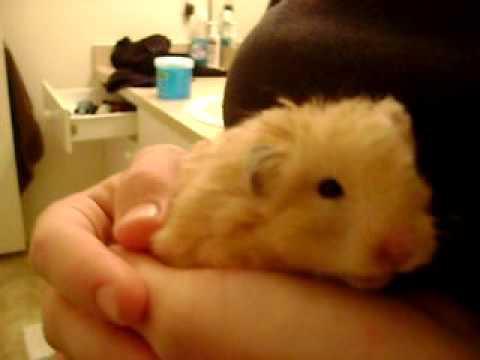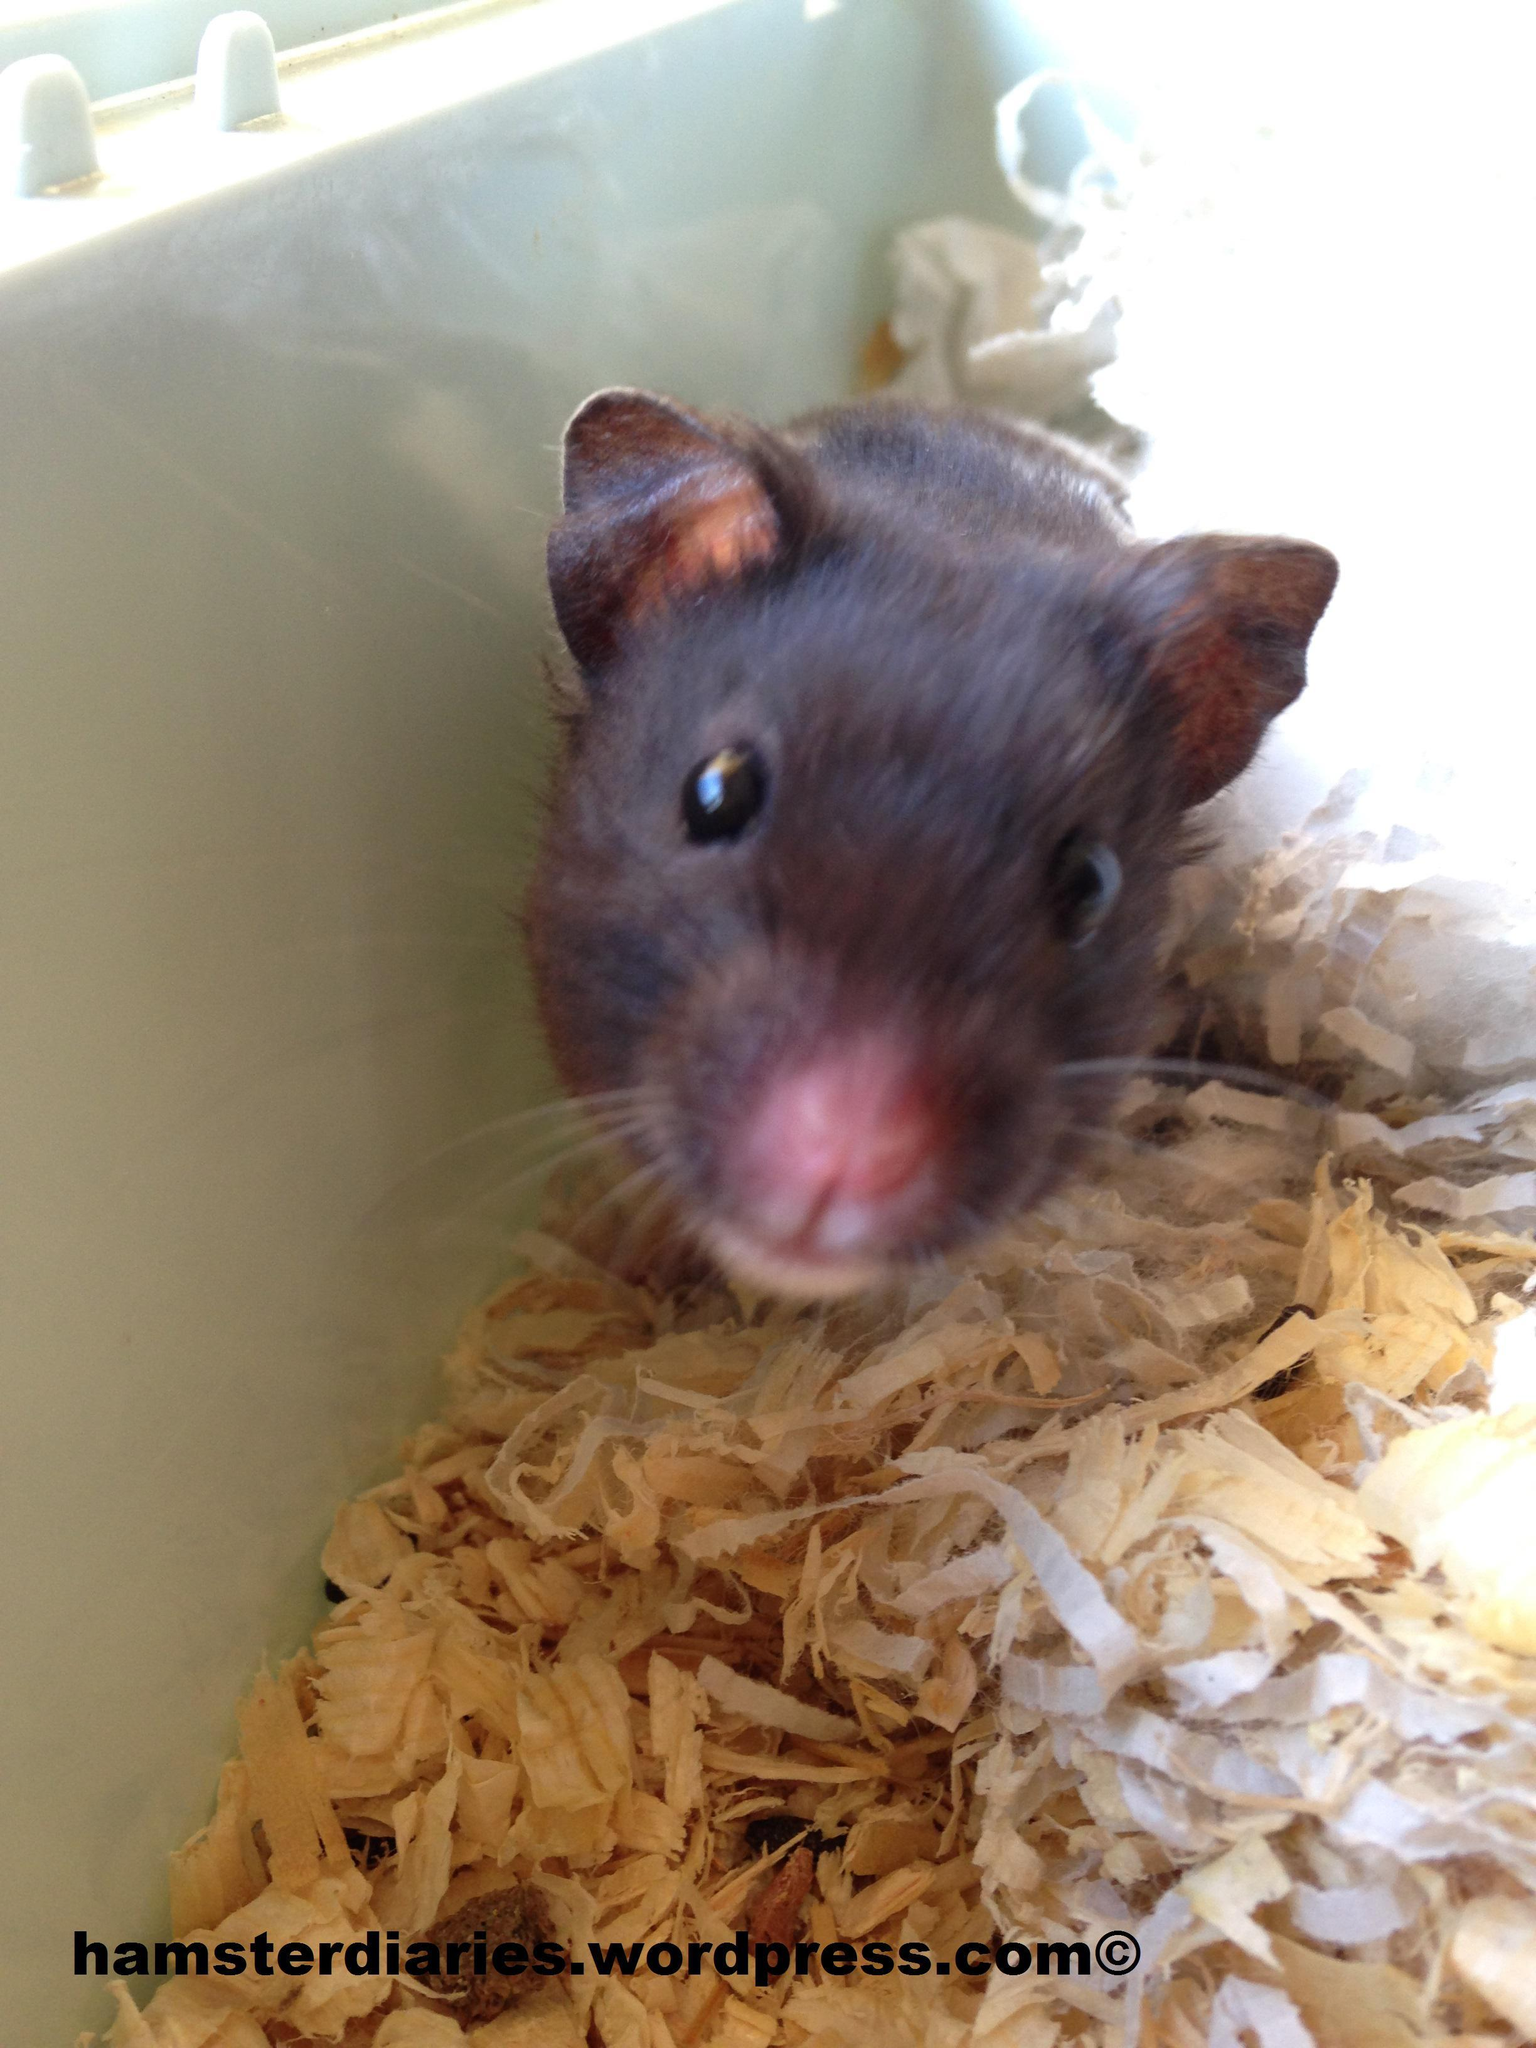The first image is the image on the left, the second image is the image on the right. Considering the images on both sides, is "A hamster is being held in someone's hand." valid? Answer yes or no. Yes. The first image is the image on the left, the second image is the image on the right. Examine the images to the left and right. Is the description "In one image the hamster is held in someone's hand and in the other the hamster is standing on sawdust." accurate? Answer yes or no. Yes. 